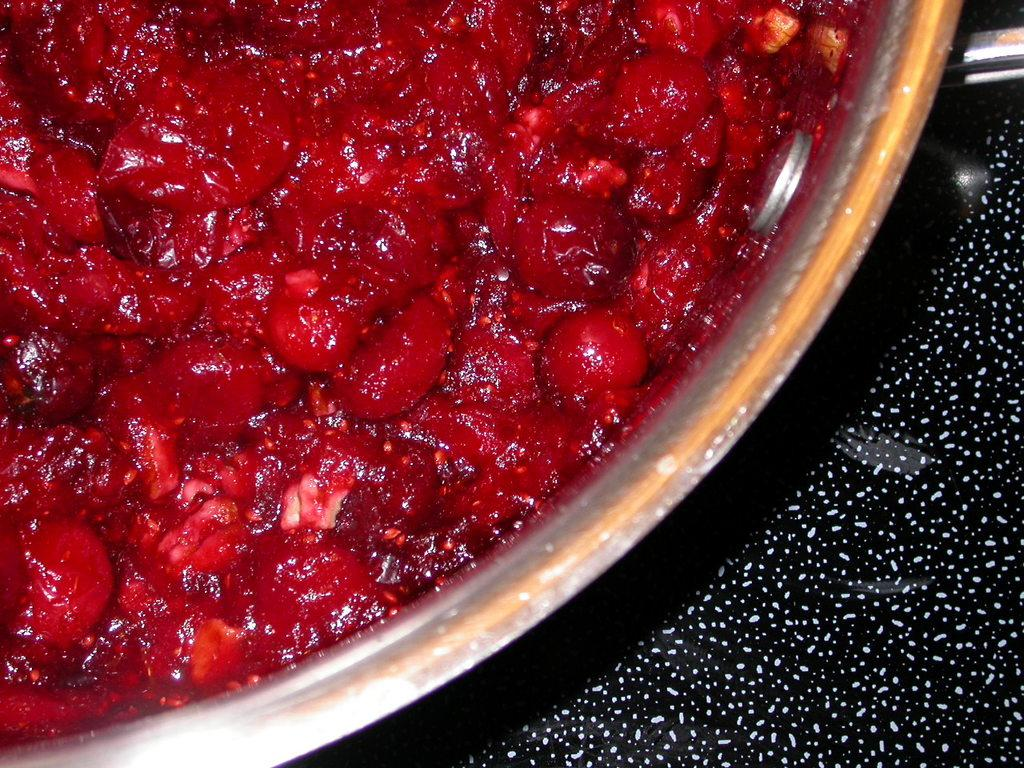What is inside the container that is visible in the image? There is a container with food items in the image. Can you describe the unspecified object in the image? Unfortunately, the provided facts do not give any details about the unspecified object, so it cannot be described. What type of mask is the kitten wearing in the image? There is no kitten or mask present in the image. 